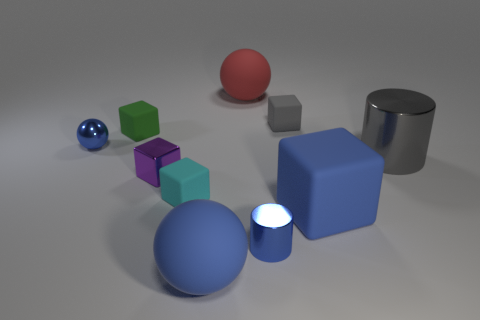Subtract all tiny cyan matte blocks. How many blocks are left? 4 Subtract all red balls. How many balls are left? 2 Subtract all cylinders. How many objects are left? 8 Subtract 0 yellow cubes. How many objects are left? 10 Subtract 2 cylinders. How many cylinders are left? 0 Subtract all cyan balls. Subtract all blue cylinders. How many balls are left? 3 Subtract all yellow blocks. How many brown balls are left? 0 Subtract all green metal things. Subtract all big balls. How many objects are left? 8 Add 8 small shiny cubes. How many small shiny cubes are left? 9 Add 1 shiny spheres. How many shiny spheres exist? 2 